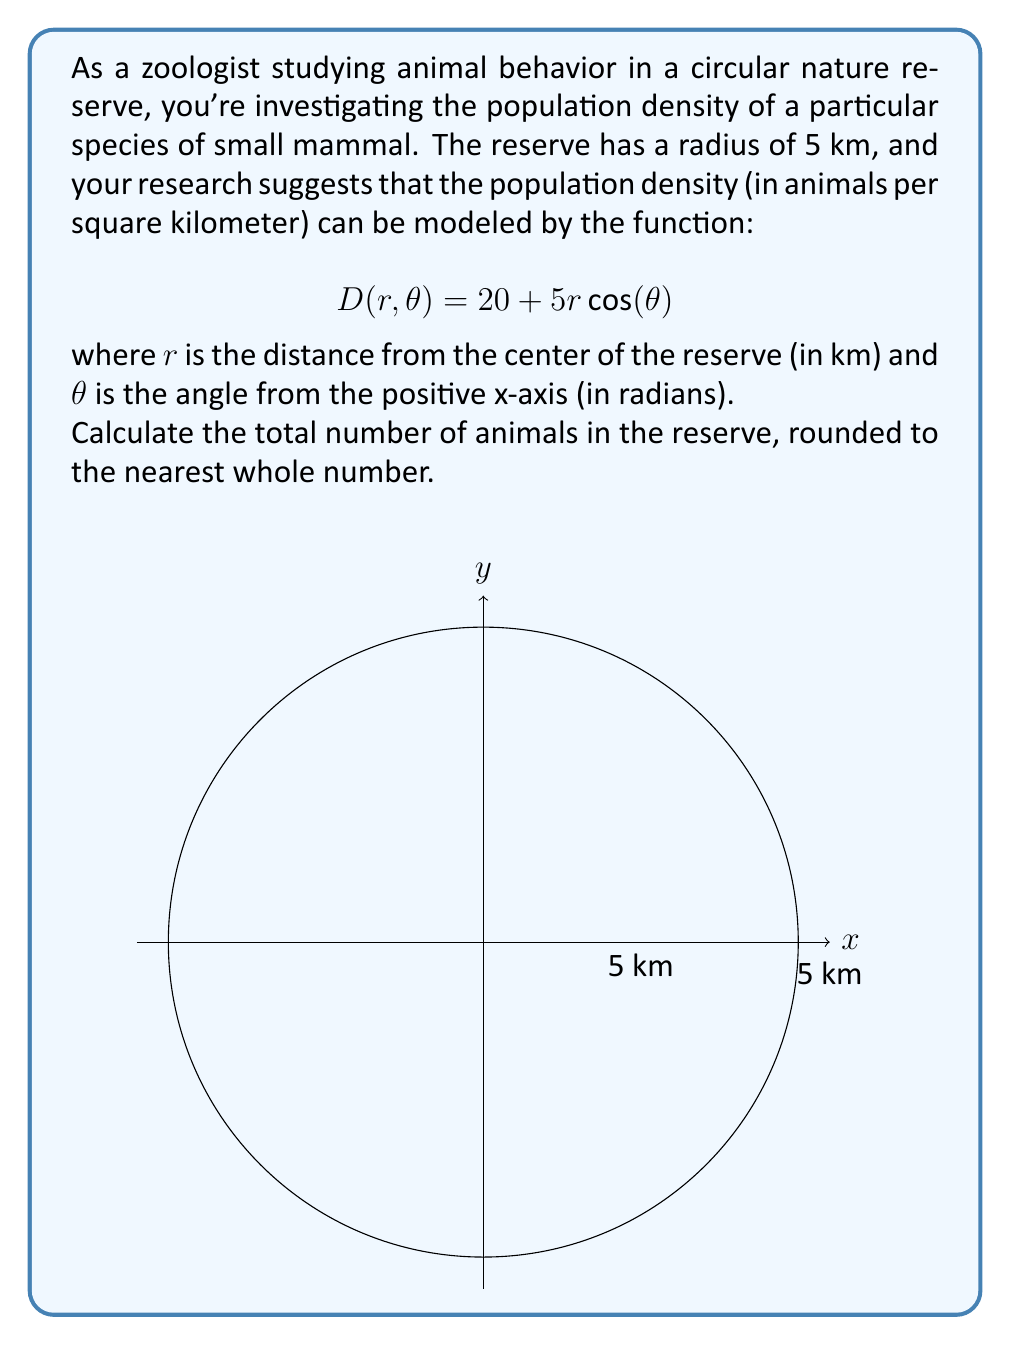Provide a solution to this math problem. To solve this problem, we need to integrate the population density function over the entire circular reserve using polar coordinates. Here's a step-by-step approach:

1) In polar coordinates, the area element is given by $dA = r dr d\theta$.

2) The total number of animals is the integral of the density function over the entire area:

   $$N = \int_0^{2\pi} \int_0^5 D(r,\theta) \cdot r \, dr \, d\theta$$

3) Substituting the given density function:

   $$N = \int_0^{2\pi} \int_0^5 (20 + 5r\cos(\theta)) \cdot r \, dr \, d\theta$$

4) Let's separate this into two integrals:

   $$N = \int_0^{2\pi} \int_0^5 20r \, dr \, d\theta + \int_0^{2\pi} \int_0^5 5r^2\cos(\theta) \, dr \, d\theta$$

5) For the first integral:
   
   $$\int_0^{2\pi} \int_0^5 20r \, dr \, d\theta = \int_0^{2\pi} [10r^2]_0^5 \, d\theta = \int_0^{2\pi} 250 \, d\theta = 250 \cdot 2\pi = 500\pi$$

6) For the second integral:
   
   $$\int_0^{2\pi} \int_0^5 5r^2\cos(\theta) \, dr \, d\theta = \int_0^{2\pi} [\frac{5}{3}r^3\cos(\theta)]_0^5 \, d\theta = \int_0^{2\pi} \frac{625}{3}\cos(\theta) \, d\theta = 0$$

   (Because the integral of cosine over a full period is zero)

7) Therefore, the total number of animals is:

   $$N = 500\pi + 0 = 500\pi$$

8) Calculating this value and rounding to the nearest whole number:

   $$500\pi \approx 1570.80$$

   Rounded to the nearest whole number: 1571
Answer: 1571 animals 